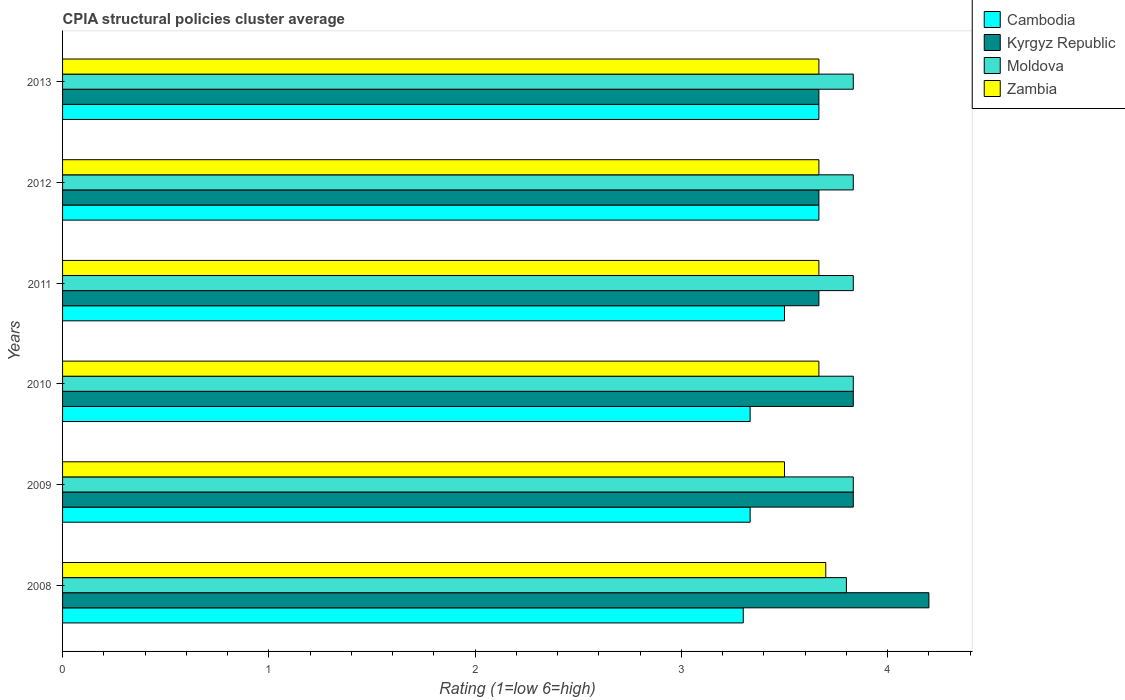Are the number of bars per tick equal to the number of legend labels?
Provide a short and direct response. Yes. Are the number of bars on each tick of the Y-axis equal?
Offer a terse response. Yes. How many bars are there on the 3rd tick from the bottom?
Offer a terse response. 4. What is the label of the 3rd group of bars from the top?
Give a very brief answer. 2011. What is the CPIA rating in Kyrgyz Republic in 2010?
Give a very brief answer. 3.83. In which year was the CPIA rating in Zambia minimum?
Offer a very short reply. 2009. What is the total CPIA rating in Kyrgyz Republic in the graph?
Make the answer very short. 22.87. What is the difference between the CPIA rating in Cambodia in 2008 and that in 2010?
Offer a very short reply. -0.03. What is the difference between the CPIA rating in Kyrgyz Republic in 2009 and the CPIA rating in Cambodia in 2012?
Keep it short and to the point. 0.17. What is the average CPIA rating in Kyrgyz Republic per year?
Ensure brevity in your answer.  3.81. In how many years, is the CPIA rating in Moldova greater than 0.8 ?
Provide a short and direct response. 6. What is the ratio of the CPIA rating in Moldova in 2010 to that in 2011?
Provide a short and direct response. 1. Is the CPIA rating in Moldova in 2010 less than that in 2011?
Your response must be concise. No. What is the difference between the highest and the second highest CPIA rating in Moldova?
Make the answer very short. 0. What is the difference between the highest and the lowest CPIA rating in Cambodia?
Keep it short and to the point. 0.37. Is the sum of the CPIA rating in Zambia in 2008 and 2010 greater than the maximum CPIA rating in Moldova across all years?
Make the answer very short. Yes. Is it the case that in every year, the sum of the CPIA rating in Zambia and CPIA rating in Cambodia is greater than the sum of CPIA rating in Moldova and CPIA rating in Kyrgyz Republic?
Provide a succinct answer. No. What does the 4th bar from the top in 2008 represents?
Your answer should be compact. Cambodia. What does the 1st bar from the bottom in 2010 represents?
Keep it short and to the point. Cambodia. How many years are there in the graph?
Give a very brief answer. 6. What is the title of the graph?
Your response must be concise. CPIA structural policies cluster average. Does "Hong Kong" appear as one of the legend labels in the graph?
Your answer should be very brief. No. What is the label or title of the X-axis?
Ensure brevity in your answer.  Rating (1=low 6=high). What is the Rating (1=low 6=high) of Cambodia in 2008?
Give a very brief answer. 3.3. What is the Rating (1=low 6=high) in Moldova in 2008?
Offer a terse response. 3.8. What is the Rating (1=low 6=high) of Cambodia in 2009?
Provide a succinct answer. 3.33. What is the Rating (1=low 6=high) of Kyrgyz Republic in 2009?
Make the answer very short. 3.83. What is the Rating (1=low 6=high) of Moldova in 2009?
Your answer should be compact. 3.83. What is the Rating (1=low 6=high) in Zambia in 2009?
Ensure brevity in your answer.  3.5. What is the Rating (1=low 6=high) of Cambodia in 2010?
Make the answer very short. 3.33. What is the Rating (1=low 6=high) of Kyrgyz Republic in 2010?
Provide a short and direct response. 3.83. What is the Rating (1=low 6=high) in Moldova in 2010?
Give a very brief answer. 3.83. What is the Rating (1=low 6=high) of Zambia in 2010?
Ensure brevity in your answer.  3.67. What is the Rating (1=low 6=high) in Kyrgyz Republic in 2011?
Offer a terse response. 3.67. What is the Rating (1=low 6=high) in Moldova in 2011?
Ensure brevity in your answer.  3.83. What is the Rating (1=low 6=high) of Zambia in 2011?
Ensure brevity in your answer.  3.67. What is the Rating (1=low 6=high) in Cambodia in 2012?
Keep it short and to the point. 3.67. What is the Rating (1=low 6=high) of Kyrgyz Republic in 2012?
Your response must be concise. 3.67. What is the Rating (1=low 6=high) of Moldova in 2012?
Give a very brief answer. 3.83. What is the Rating (1=low 6=high) of Zambia in 2012?
Make the answer very short. 3.67. What is the Rating (1=low 6=high) of Cambodia in 2013?
Your answer should be very brief. 3.67. What is the Rating (1=low 6=high) of Kyrgyz Republic in 2013?
Provide a short and direct response. 3.67. What is the Rating (1=low 6=high) of Moldova in 2013?
Provide a succinct answer. 3.83. What is the Rating (1=low 6=high) of Zambia in 2013?
Keep it short and to the point. 3.67. Across all years, what is the maximum Rating (1=low 6=high) of Cambodia?
Give a very brief answer. 3.67. Across all years, what is the maximum Rating (1=low 6=high) in Moldova?
Provide a short and direct response. 3.83. Across all years, what is the minimum Rating (1=low 6=high) of Cambodia?
Your answer should be very brief. 3.3. Across all years, what is the minimum Rating (1=low 6=high) in Kyrgyz Republic?
Your answer should be compact. 3.67. What is the total Rating (1=low 6=high) in Cambodia in the graph?
Ensure brevity in your answer.  20.8. What is the total Rating (1=low 6=high) of Kyrgyz Republic in the graph?
Provide a succinct answer. 22.87. What is the total Rating (1=low 6=high) in Moldova in the graph?
Your answer should be very brief. 22.97. What is the total Rating (1=low 6=high) in Zambia in the graph?
Ensure brevity in your answer.  21.87. What is the difference between the Rating (1=low 6=high) in Cambodia in 2008 and that in 2009?
Make the answer very short. -0.03. What is the difference between the Rating (1=low 6=high) of Kyrgyz Republic in 2008 and that in 2009?
Provide a short and direct response. 0.37. What is the difference between the Rating (1=low 6=high) in Moldova in 2008 and that in 2009?
Provide a short and direct response. -0.03. What is the difference between the Rating (1=low 6=high) in Zambia in 2008 and that in 2009?
Make the answer very short. 0.2. What is the difference between the Rating (1=low 6=high) in Cambodia in 2008 and that in 2010?
Offer a terse response. -0.03. What is the difference between the Rating (1=low 6=high) of Kyrgyz Republic in 2008 and that in 2010?
Offer a very short reply. 0.37. What is the difference between the Rating (1=low 6=high) of Moldova in 2008 and that in 2010?
Your response must be concise. -0.03. What is the difference between the Rating (1=low 6=high) of Zambia in 2008 and that in 2010?
Your answer should be compact. 0.03. What is the difference between the Rating (1=low 6=high) in Kyrgyz Republic in 2008 and that in 2011?
Your response must be concise. 0.53. What is the difference between the Rating (1=low 6=high) in Moldova in 2008 and that in 2011?
Keep it short and to the point. -0.03. What is the difference between the Rating (1=low 6=high) in Cambodia in 2008 and that in 2012?
Provide a succinct answer. -0.37. What is the difference between the Rating (1=low 6=high) in Kyrgyz Republic in 2008 and that in 2012?
Make the answer very short. 0.53. What is the difference between the Rating (1=low 6=high) of Moldova in 2008 and that in 2012?
Ensure brevity in your answer.  -0.03. What is the difference between the Rating (1=low 6=high) of Zambia in 2008 and that in 2012?
Offer a very short reply. 0.03. What is the difference between the Rating (1=low 6=high) of Cambodia in 2008 and that in 2013?
Your response must be concise. -0.37. What is the difference between the Rating (1=low 6=high) of Kyrgyz Republic in 2008 and that in 2013?
Your answer should be compact. 0.53. What is the difference between the Rating (1=low 6=high) in Moldova in 2008 and that in 2013?
Your answer should be very brief. -0.03. What is the difference between the Rating (1=low 6=high) in Zambia in 2008 and that in 2013?
Your answer should be compact. 0.03. What is the difference between the Rating (1=low 6=high) of Cambodia in 2009 and that in 2010?
Your answer should be very brief. 0. What is the difference between the Rating (1=low 6=high) of Kyrgyz Republic in 2009 and that in 2010?
Keep it short and to the point. 0. What is the difference between the Rating (1=low 6=high) of Moldova in 2009 and that in 2010?
Your answer should be very brief. 0. What is the difference between the Rating (1=low 6=high) in Zambia in 2009 and that in 2010?
Ensure brevity in your answer.  -0.17. What is the difference between the Rating (1=low 6=high) of Kyrgyz Republic in 2009 and that in 2011?
Offer a terse response. 0.17. What is the difference between the Rating (1=low 6=high) in Moldova in 2009 and that in 2011?
Offer a terse response. 0. What is the difference between the Rating (1=low 6=high) in Zambia in 2009 and that in 2011?
Make the answer very short. -0.17. What is the difference between the Rating (1=low 6=high) of Zambia in 2009 and that in 2012?
Offer a very short reply. -0.17. What is the difference between the Rating (1=low 6=high) in Zambia in 2009 and that in 2013?
Your response must be concise. -0.17. What is the difference between the Rating (1=low 6=high) of Cambodia in 2010 and that in 2011?
Offer a terse response. -0.17. What is the difference between the Rating (1=low 6=high) of Kyrgyz Republic in 2010 and that in 2011?
Your answer should be very brief. 0.17. What is the difference between the Rating (1=low 6=high) of Moldova in 2010 and that in 2011?
Offer a terse response. 0. What is the difference between the Rating (1=low 6=high) in Zambia in 2010 and that in 2011?
Your answer should be compact. 0. What is the difference between the Rating (1=low 6=high) in Cambodia in 2010 and that in 2012?
Give a very brief answer. -0.33. What is the difference between the Rating (1=low 6=high) of Moldova in 2010 and that in 2012?
Make the answer very short. 0. What is the difference between the Rating (1=low 6=high) of Cambodia in 2010 and that in 2013?
Provide a short and direct response. -0.33. What is the difference between the Rating (1=low 6=high) of Moldova in 2010 and that in 2013?
Provide a short and direct response. 0. What is the difference between the Rating (1=low 6=high) of Zambia in 2010 and that in 2013?
Your response must be concise. 0. What is the difference between the Rating (1=low 6=high) of Moldova in 2011 and that in 2012?
Provide a succinct answer. 0. What is the difference between the Rating (1=low 6=high) of Zambia in 2011 and that in 2012?
Keep it short and to the point. 0. What is the difference between the Rating (1=low 6=high) in Kyrgyz Republic in 2012 and that in 2013?
Ensure brevity in your answer.  0. What is the difference between the Rating (1=low 6=high) in Cambodia in 2008 and the Rating (1=low 6=high) in Kyrgyz Republic in 2009?
Make the answer very short. -0.53. What is the difference between the Rating (1=low 6=high) in Cambodia in 2008 and the Rating (1=low 6=high) in Moldova in 2009?
Offer a very short reply. -0.53. What is the difference between the Rating (1=low 6=high) in Cambodia in 2008 and the Rating (1=low 6=high) in Zambia in 2009?
Provide a succinct answer. -0.2. What is the difference between the Rating (1=low 6=high) in Kyrgyz Republic in 2008 and the Rating (1=low 6=high) in Moldova in 2009?
Ensure brevity in your answer.  0.37. What is the difference between the Rating (1=low 6=high) of Kyrgyz Republic in 2008 and the Rating (1=low 6=high) of Zambia in 2009?
Your response must be concise. 0.7. What is the difference between the Rating (1=low 6=high) in Cambodia in 2008 and the Rating (1=low 6=high) in Kyrgyz Republic in 2010?
Offer a very short reply. -0.53. What is the difference between the Rating (1=low 6=high) of Cambodia in 2008 and the Rating (1=low 6=high) of Moldova in 2010?
Your answer should be compact. -0.53. What is the difference between the Rating (1=low 6=high) of Cambodia in 2008 and the Rating (1=low 6=high) of Zambia in 2010?
Ensure brevity in your answer.  -0.37. What is the difference between the Rating (1=low 6=high) of Kyrgyz Republic in 2008 and the Rating (1=low 6=high) of Moldova in 2010?
Provide a short and direct response. 0.37. What is the difference between the Rating (1=low 6=high) in Kyrgyz Republic in 2008 and the Rating (1=low 6=high) in Zambia in 2010?
Provide a short and direct response. 0.53. What is the difference between the Rating (1=low 6=high) of Moldova in 2008 and the Rating (1=low 6=high) of Zambia in 2010?
Make the answer very short. 0.13. What is the difference between the Rating (1=low 6=high) of Cambodia in 2008 and the Rating (1=low 6=high) of Kyrgyz Republic in 2011?
Provide a short and direct response. -0.37. What is the difference between the Rating (1=low 6=high) of Cambodia in 2008 and the Rating (1=low 6=high) of Moldova in 2011?
Provide a short and direct response. -0.53. What is the difference between the Rating (1=low 6=high) in Cambodia in 2008 and the Rating (1=low 6=high) in Zambia in 2011?
Your answer should be very brief. -0.37. What is the difference between the Rating (1=low 6=high) in Kyrgyz Republic in 2008 and the Rating (1=low 6=high) in Moldova in 2011?
Your response must be concise. 0.37. What is the difference between the Rating (1=low 6=high) of Kyrgyz Republic in 2008 and the Rating (1=low 6=high) of Zambia in 2011?
Your answer should be compact. 0.53. What is the difference between the Rating (1=low 6=high) in Moldova in 2008 and the Rating (1=low 6=high) in Zambia in 2011?
Offer a terse response. 0.13. What is the difference between the Rating (1=low 6=high) in Cambodia in 2008 and the Rating (1=low 6=high) in Kyrgyz Republic in 2012?
Provide a succinct answer. -0.37. What is the difference between the Rating (1=low 6=high) of Cambodia in 2008 and the Rating (1=low 6=high) of Moldova in 2012?
Your answer should be very brief. -0.53. What is the difference between the Rating (1=low 6=high) of Cambodia in 2008 and the Rating (1=low 6=high) of Zambia in 2012?
Offer a very short reply. -0.37. What is the difference between the Rating (1=low 6=high) in Kyrgyz Republic in 2008 and the Rating (1=low 6=high) in Moldova in 2012?
Your response must be concise. 0.37. What is the difference between the Rating (1=low 6=high) in Kyrgyz Republic in 2008 and the Rating (1=low 6=high) in Zambia in 2012?
Provide a succinct answer. 0.53. What is the difference between the Rating (1=low 6=high) of Moldova in 2008 and the Rating (1=low 6=high) of Zambia in 2012?
Your answer should be very brief. 0.13. What is the difference between the Rating (1=low 6=high) of Cambodia in 2008 and the Rating (1=low 6=high) of Kyrgyz Republic in 2013?
Your answer should be very brief. -0.37. What is the difference between the Rating (1=low 6=high) in Cambodia in 2008 and the Rating (1=low 6=high) in Moldova in 2013?
Your answer should be compact. -0.53. What is the difference between the Rating (1=low 6=high) in Cambodia in 2008 and the Rating (1=low 6=high) in Zambia in 2013?
Provide a succinct answer. -0.37. What is the difference between the Rating (1=low 6=high) of Kyrgyz Republic in 2008 and the Rating (1=low 6=high) of Moldova in 2013?
Give a very brief answer. 0.37. What is the difference between the Rating (1=low 6=high) of Kyrgyz Republic in 2008 and the Rating (1=low 6=high) of Zambia in 2013?
Your response must be concise. 0.53. What is the difference between the Rating (1=low 6=high) of Moldova in 2008 and the Rating (1=low 6=high) of Zambia in 2013?
Your answer should be very brief. 0.13. What is the difference between the Rating (1=low 6=high) in Kyrgyz Republic in 2009 and the Rating (1=low 6=high) in Moldova in 2010?
Your response must be concise. 0. What is the difference between the Rating (1=low 6=high) of Kyrgyz Republic in 2009 and the Rating (1=low 6=high) of Zambia in 2010?
Your answer should be very brief. 0.17. What is the difference between the Rating (1=low 6=high) in Moldova in 2009 and the Rating (1=low 6=high) in Zambia in 2010?
Offer a very short reply. 0.17. What is the difference between the Rating (1=low 6=high) in Cambodia in 2009 and the Rating (1=low 6=high) in Zambia in 2011?
Offer a very short reply. -0.33. What is the difference between the Rating (1=low 6=high) in Kyrgyz Republic in 2009 and the Rating (1=low 6=high) in Zambia in 2011?
Your answer should be very brief. 0.17. What is the difference between the Rating (1=low 6=high) of Moldova in 2009 and the Rating (1=low 6=high) of Zambia in 2011?
Your answer should be very brief. 0.17. What is the difference between the Rating (1=low 6=high) in Cambodia in 2009 and the Rating (1=low 6=high) in Kyrgyz Republic in 2012?
Make the answer very short. -0.33. What is the difference between the Rating (1=low 6=high) in Kyrgyz Republic in 2009 and the Rating (1=low 6=high) in Moldova in 2012?
Make the answer very short. 0. What is the difference between the Rating (1=low 6=high) of Moldova in 2009 and the Rating (1=low 6=high) of Zambia in 2012?
Your answer should be very brief. 0.17. What is the difference between the Rating (1=low 6=high) in Cambodia in 2009 and the Rating (1=low 6=high) in Moldova in 2013?
Provide a succinct answer. -0.5. What is the difference between the Rating (1=low 6=high) in Kyrgyz Republic in 2009 and the Rating (1=low 6=high) in Moldova in 2013?
Keep it short and to the point. 0. What is the difference between the Rating (1=low 6=high) in Moldova in 2009 and the Rating (1=low 6=high) in Zambia in 2013?
Offer a terse response. 0.17. What is the difference between the Rating (1=low 6=high) of Cambodia in 2010 and the Rating (1=low 6=high) of Moldova in 2011?
Your answer should be compact. -0.5. What is the difference between the Rating (1=low 6=high) of Cambodia in 2010 and the Rating (1=low 6=high) of Zambia in 2011?
Ensure brevity in your answer.  -0.33. What is the difference between the Rating (1=low 6=high) of Kyrgyz Republic in 2010 and the Rating (1=low 6=high) of Zambia in 2011?
Offer a very short reply. 0.17. What is the difference between the Rating (1=low 6=high) of Moldova in 2010 and the Rating (1=low 6=high) of Zambia in 2011?
Provide a short and direct response. 0.17. What is the difference between the Rating (1=low 6=high) in Cambodia in 2010 and the Rating (1=low 6=high) in Moldova in 2012?
Your response must be concise. -0.5. What is the difference between the Rating (1=low 6=high) in Kyrgyz Republic in 2010 and the Rating (1=low 6=high) in Zambia in 2012?
Offer a terse response. 0.17. What is the difference between the Rating (1=low 6=high) of Cambodia in 2010 and the Rating (1=low 6=high) of Kyrgyz Republic in 2013?
Give a very brief answer. -0.33. What is the difference between the Rating (1=low 6=high) in Cambodia in 2010 and the Rating (1=low 6=high) in Moldova in 2013?
Provide a short and direct response. -0.5. What is the difference between the Rating (1=low 6=high) in Cambodia in 2010 and the Rating (1=low 6=high) in Zambia in 2013?
Offer a terse response. -0.33. What is the difference between the Rating (1=low 6=high) in Kyrgyz Republic in 2010 and the Rating (1=low 6=high) in Moldova in 2013?
Provide a succinct answer. 0. What is the difference between the Rating (1=low 6=high) of Kyrgyz Republic in 2010 and the Rating (1=low 6=high) of Zambia in 2013?
Make the answer very short. 0.17. What is the difference between the Rating (1=low 6=high) in Cambodia in 2011 and the Rating (1=low 6=high) in Moldova in 2012?
Offer a terse response. -0.33. What is the difference between the Rating (1=low 6=high) of Cambodia in 2011 and the Rating (1=low 6=high) of Zambia in 2012?
Ensure brevity in your answer.  -0.17. What is the difference between the Rating (1=low 6=high) in Kyrgyz Republic in 2011 and the Rating (1=low 6=high) in Zambia in 2012?
Your answer should be compact. 0. What is the difference between the Rating (1=low 6=high) in Cambodia in 2011 and the Rating (1=low 6=high) in Kyrgyz Republic in 2013?
Your answer should be very brief. -0.17. What is the difference between the Rating (1=low 6=high) in Cambodia in 2011 and the Rating (1=low 6=high) in Moldova in 2013?
Make the answer very short. -0.33. What is the difference between the Rating (1=low 6=high) of Kyrgyz Republic in 2011 and the Rating (1=low 6=high) of Moldova in 2013?
Your response must be concise. -0.17. What is the difference between the Rating (1=low 6=high) of Moldova in 2011 and the Rating (1=low 6=high) of Zambia in 2013?
Provide a short and direct response. 0.17. What is the difference between the Rating (1=low 6=high) of Cambodia in 2012 and the Rating (1=low 6=high) of Zambia in 2013?
Offer a very short reply. 0. What is the difference between the Rating (1=low 6=high) in Kyrgyz Republic in 2012 and the Rating (1=low 6=high) in Moldova in 2013?
Keep it short and to the point. -0.17. What is the average Rating (1=low 6=high) of Cambodia per year?
Ensure brevity in your answer.  3.47. What is the average Rating (1=low 6=high) of Kyrgyz Republic per year?
Your answer should be compact. 3.81. What is the average Rating (1=low 6=high) in Moldova per year?
Provide a short and direct response. 3.83. What is the average Rating (1=low 6=high) of Zambia per year?
Your answer should be compact. 3.64. In the year 2008, what is the difference between the Rating (1=low 6=high) of Cambodia and Rating (1=low 6=high) of Zambia?
Ensure brevity in your answer.  -0.4. In the year 2008, what is the difference between the Rating (1=low 6=high) in Kyrgyz Republic and Rating (1=low 6=high) in Zambia?
Provide a short and direct response. 0.5. In the year 2008, what is the difference between the Rating (1=low 6=high) in Moldova and Rating (1=low 6=high) in Zambia?
Provide a short and direct response. 0.1. In the year 2009, what is the difference between the Rating (1=low 6=high) of Cambodia and Rating (1=low 6=high) of Kyrgyz Republic?
Provide a short and direct response. -0.5. In the year 2009, what is the difference between the Rating (1=low 6=high) in Cambodia and Rating (1=low 6=high) in Zambia?
Your answer should be very brief. -0.17. In the year 2009, what is the difference between the Rating (1=low 6=high) in Kyrgyz Republic and Rating (1=low 6=high) in Moldova?
Your response must be concise. 0. In the year 2009, what is the difference between the Rating (1=low 6=high) of Moldova and Rating (1=low 6=high) of Zambia?
Your answer should be compact. 0.33. In the year 2010, what is the difference between the Rating (1=low 6=high) of Cambodia and Rating (1=low 6=high) of Zambia?
Keep it short and to the point. -0.33. In the year 2011, what is the difference between the Rating (1=low 6=high) in Cambodia and Rating (1=low 6=high) in Kyrgyz Republic?
Your answer should be compact. -0.17. In the year 2011, what is the difference between the Rating (1=low 6=high) of Cambodia and Rating (1=low 6=high) of Zambia?
Make the answer very short. -0.17. In the year 2011, what is the difference between the Rating (1=low 6=high) of Moldova and Rating (1=low 6=high) of Zambia?
Your response must be concise. 0.17. In the year 2012, what is the difference between the Rating (1=low 6=high) of Cambodia and Rating (1=low 6=high) of Zambia?
Provide a short and direct response. 0. In the year 2012, what is the difference between the Rating (1=low 6=high) in Kyrgyz Republic and Rating (1=low 6=high) in Moldova?
Give a very brief answer. -0.17. In the year 2013, what is the difference between the Rating (1=low 6=high) in Cambodia and Rating (1=low 6=high) in Moldova?
Give a very brief answer. -0.17. In the year 2013, what is the difference between the Rating (1=low 6=high) of Cambodia and Rating (1=low 6=high) of Zambia?
Your answer should be compact. 0. In the year 2013, what is the difference between the Rating (1=low 6=high) of Kyrgyz Republic and Rating (1=low 6=high) of Moldova?
Ensure brevity in your answer.  -0.17. In the year 2013, what is the difference between the Rating (1=low 6=high) of Moldova and Rating (1=low 6=high) of Zambia?
Your response must be concise. 0.17. What is the ratio of the Rating (1=low 6=high) in Kyrgyz Republic in 2008 to that in 2009?
Offer a very short reply. 1.1. What is the ratio of the Rating (1=low 6=high) of Zambia in 2008 to that in 2009?
Offer a terse response. 1.06. What is the ratio of the Rating (1=low 6=high) in Kyrgyz Republic in 2008 to that in 2010?
Provide a short and direct response. 1.1. What is the ratio of the Rating (1=low 6=high) in Zambia in 2008 to that in 2010?
Your answer should be very brief. 1.01. What is the ratio of the Rating (1=low 6=high) of Cambodia in 2008 to that in 2011?
Keep it short and to the point. 0.94. What is the ratio of the Rating (1=low 6=high) in Kyrgyz Republic in 2008 to that in 2011?
Make the answer very short. 1.15. What is the ratio of the Rating (1=low 6=high) of Moldova in 2008 to that in 2011?
Give a very brief answer. 0.99. What is the ratio of the Rating (1=low 6=high) of Zambia in 2008 to that in 2011?
Provide a short and direct response. 1.01. What is the ratio of the Rating (1=low 6=high) of Cambodia in 2008 to that in 2012?
Your response must be concise. 0.9. What is the ratio of the Rating (1=low 6=high) of Kyrgyz Republic in 2008 to that in 2012?
Your response must be concise. 1.15. What is the ratio of the Rating (1=low 6=high) of Moldova in 2008 to that in 2012?
Provide a short and direct response. 0.99. What is the ratio of the Rating (1=low 6=high) of Zambia in 2008 to that in 2012?
Offer a very short reply. 1.01. What is the ratio of the Rating (1=low 6=high) of Kyrgyz Republic in 2008 to that in 2013?
Offer a terse response. 1.15. What is the ratio of the Rating (1=low 6=high) of Zambia in 2008 to that in 2013?
Provide a short and direct response. 1.01. What is the ratio of the Rating (1=low 6=high) of Kyrgyz Republic in 2009 to that in 2010?
Ensure brevity in your answer.  1. What is the ratio of the Rating (1=low 6=high) in Moldova in 2009 to that in 2010?
Ensure brevity in your answer.  1. What is the ratio of the Rating (1=low 6=high) of Zambia in 2009 to that in 2010?
Give a very brief answer. 0.95. What is the ratio of the Rating (1=low 6=high) in Cambodia in 2009 to that in 2011?
Give a very brief answer. 0.95. What is the ratio of the Rating (1=low 6=high) in Kyrgyz Republic in 2009 to that in 2011?
Provide a short and direct response. 1.05. What is the ratio of the Rating (1=low 6=high) in Moldova in 2009 to that in 2011?
Provide a short and direct response. 1. What is the ratio of the Rating (1=low 6=high) of Zambia in 2009 to that in 2011?
Provide a succinct answer. 0.95. What is the ratio of the Rating (1=low 6=high) in Kyrgyz Republic in 2009 to that in 2012?
Provide a succinct answer. 1.05. What is the ratio of the Rating (1=low 6=high) of Moldova in 2009 to that in 2012?
Give a very brief answer. 1. What is the ratio of the Rating (1=low 6=high) in Zambia in 2009 to that in 2012?
Your response must be concise. 0.95. What is the ratio of the Rating (1=low 6=high) of Cambodia in 2009 to that in 2013?
Keep it short and to the point. 0.91. What is the ratio of the Rating (1=low 6=high) of Kyrgyz Republic in 2009 to that in 2013?
Keep it short and to the point. 1.05. What is the ratio of the Rating (1=low 6=high) in Moldova in 2009 to that in 2013?
Offer a very short reply. 1. What is the ratio of the Rating (1=low 6=high) of Zambia in 2009 to that in 2013?
Offer a terse response. 0.95. What is the ratio of the Rating (1=low 6=high) of Kyrgyz Republic in 2010 to that in 2011?
Your answer should be compact. 1.05. What is the ratio of the Rating (1=low 6=high) in Moldova in 2010 to that in 2011?
Your answer should be compact. 1. What is the ratio of the Rating (1=low 6=high) in Cambodia in 2010 to that in 2012?
Your answer should be compact. 0.91. What is the ratio of the Rating (1=low 6=high) of Kyrgyz Republic in 2010 to that in 2012?
Ensure brevity in your answer.  1.05. What is the ratio of the Rating (1=low 6=high) in Cambodia in 2010 to that in 2013?
Keep it short and to the point. 0.91. What is the ratio of the Rating (1=low 6=high) of Kyrgyz Republic in 2010 to that in 2013?
Offer a terse response. 1.05. What is the ratio of the Rating (1=low 6=high) of Moldova in 2010 to that in 2013?
Make the answer very short. 1. What is the ratio of the Rating (1=low 6=high) in Cambodia in 2011 to that in 2012?
Your answer should be very brief. 0.95. What is the ratio of the Rating (1=low 6=high) of Moldova in 2011 to that in 2012?
Make the answer very short. 1. What is the ratio of the Rating (1=low 6=high) in Cambodia in 2011 to that in 2013?
Make the answer very short. 0.95. What is the ratio of the Rating (1=low 6=high) of Zambia in 2011 to that in 2013?
Your answer should be very brief. 1. What is the ratio of the Rating (1=low 6=high) of Cambodia in 2012 to that in 2013?
Offer a terse response. 1. What is the ratio of the Rating (1=low 6=high) in Kyrgyz Republic in 2012 to that in 2013?
Provide a short and direct response. 1. What is the ratio of the Rating (1=low 6=high) in Moldova in 2012 to that in 2013?
Offer a terse response. 1. What is the ratio of the Rating (1=low 6=high) of Zambia in 2012 to that in 2013?
Offer a very short reply. 1. What is the difference between the highest and the second highest Rating (1=low 6=high) of Cambodia?
Your answer should be very brief. 0. What is the difference between the highest and the second highest Rating (1=low 6=high) of Kyrgyz Republic?
Offer a very short reply. 0.37. What is the difference between the highest and the second highest Rating (1=low 6=high) in Moldova?
Provide a succinct answer. 0. What is the difference between the highest and the lowest Rating (1=low 6=high) in Cambodia?
Offer a terse response. 0.37. What is the difference between the highest and the lowest Rating (1=low 6=high) of Kyrgyz Republic?
Give a very brief answer. 0.53. What is the difference between the highest and the lowest Rating (1=low 6=high) in Moldova?
Keep it short and to the point. 0.03. What is the difference between the highest and the lowest Rating (1=low 6=high) of Zambia?
Your response must be concise. 0.2. 